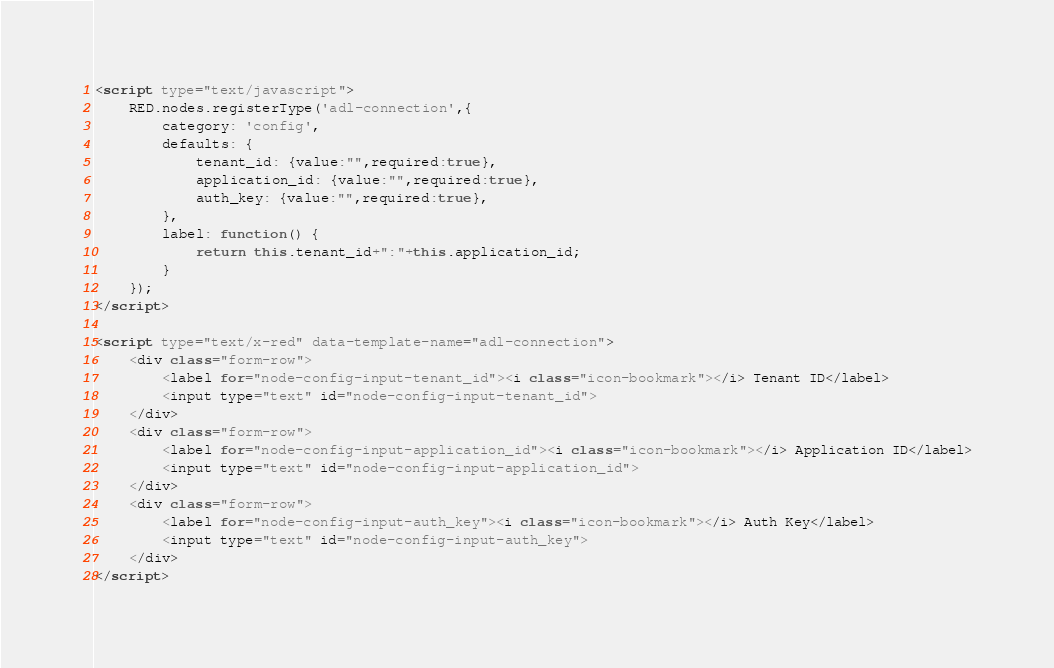Convert code to text. <code><loc_0><loc_0><loc_500><loc_500><_HTML_><script type="text/javascript">
    RED.nodes.registerType('adl-connection',{
        category: 'config',
        defaults: {
            tenant_id: {value:"",required:true}, 
            application_id: {value:"",required:true},
            auth_key: {value:"",required:true},
        },
        label: function() {
            return this.tenant_id+":"+this.application_id;
        }
    });
</script>

<script type="text/x-red" data-template-name="adl-connection">
    <div class="form-row">
        <label for="node-config-input-tenant_id"><i class="icon-bookmark"></i> Tenant ID</label>
        <input type="text" id="node-config-input-tenant_id">
    </div>
    <div class="form-row">
        <label for="node-config-input-application_id"><i class="icon-bookmark"></i> Application ID</label>
        <input type="text" id="node-config-input-application_id">
    </div>
    <div class="form-row">
        <label for="node-config-input-auth_key"><i class="icon-bookmark"></i> Auth Key</label>
        <input type="text" id="node-config-input-auth_key">
    </div>
</script></code> 